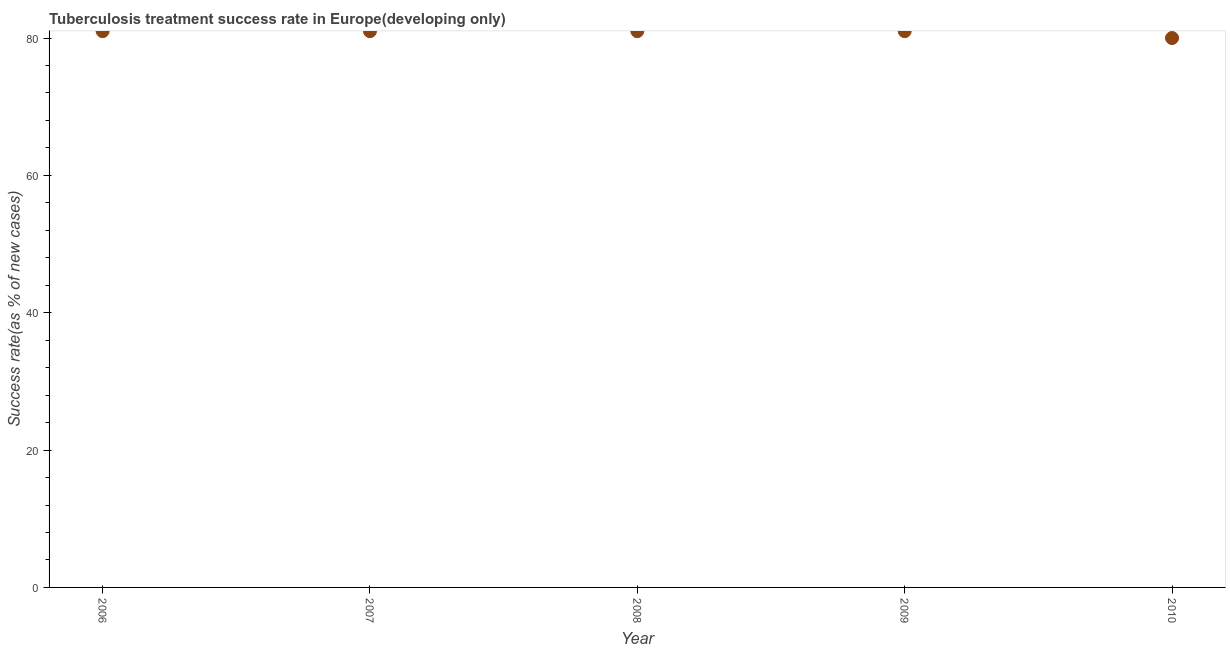What is the tuberculosis treatment success rate in 2007?
Ensure brevity in your answer.  81. Across all years, what is the maximum tuberculosis treatment success rate?
Provide a succinct answer. 81. Across all years, what is the minimum tuberculosis treatment success rate?
Provide a succinct answer. 80. In which year was the tuberculosis treatment success rate minimum?
Your response must be concise. 2010. What is the sum of the tuberculosis treatment success rate?
Your answer should be compact. 404. What is the difference between the tuberculosis treatment success rate in 2008 and 2010?
Your response must be concise. 1. What is the average tuberculosis treatment success rate per year?
Offer a very short reply. 80.8. Is the difference between the tuberculosis treatment success rate in 2007 and 2009 greater than the difference between any two years?
Your answer should be very brief. No. What is the difference between the highest and the lowest tuberculosis treatment success rate?
Make the answer very short. 1. In how many years, is the tuberculosis treatment success rate greater than the average tuberculosis treatment success rate taken over all years?
Provide a short and direct response. 4. Does the tuberculosis treatment success rate monotonically increase over the years?
Offer a terse response. No. How many dotlines are there?
Offer a terse response. 1. What is the difference between two consecutive major ticks on the Y-axis?
Provide a succinct answer. 20. Are the values on the major ticks of Y-axis written in scientific E-notation?
Your answer should be compact. No. Does the graph contain grids?
Ensure brevity in your answer.  No. What is the title of the graph?
Provide a short and direct response. Tuberculosis treatment success rate in Europe(developing only). What is the label or title of the X-axis?
Your answer should be very brief. Year. What is the label or title of the Y-axis?
Make the answer very short. Success rate(as % of new cases). What is the Success rate(as % of new cases) in 2006?
Your answer should be very brief. 81. What is the Success rate(as % of new cases) in 2009?
Make the answer very short. 81. What is the difference between the Success rate(as % of new cases) in 2006 and 2009?
Your answer should be very brief. 0. What is the difference between the Success rate(as % of new cases) in 2006 and 2010?
Your answer should be compact. 1. What is the difference between the Success rate(as % of new cases) in 2007 and 2009?
Keep it short and to the point. 0. What is the difference between the Success rate(as % of new cases) in 2007 and 2010?
Ensure brevity in your answer.  1. What is the difference between the Success rate(as % of new cases) in 2009 and 2010?
Offer a terse response. 1. What is the ratio of the Success rate(as % of new cases) in 2006 to that in 2007?
Your response must be concise. 1. What is the ratio of the Success rate(as % of new cases) in 2006 to that in 2010?
Give a very brief answer. 1.01. What is the ratio of the Success rate(as % of new cases) in 2007 to that in 2009?
Your answer should be very brief. 1. What is the ratio of the Success rate(as % of new cases) in 2009 to that in 2010?
Offer a terse response. 1.01. 